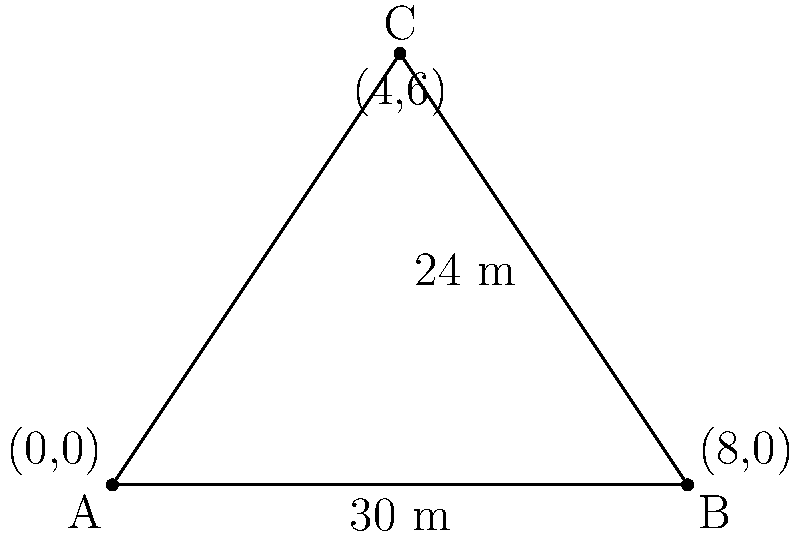A traditional Telugu temple gopuram has a triangular cross-section as shown in the diagram. If the base of the gopuram is 30 meters wide and its height is 24 meters, what is the angle of inclination (in degrees) of the gopuram's side with respect to the ground? Let's approach this step-by-step:

1) The diagram shows a right-angled triangle. We need to find the angle between the base and the hypotenuse.

2) We know:
   - The base (width) of the gopuram = 30 meters
   - The height of the gopuram = 24 meters

3) In this right-angled triangle:
   - The base is half of the total width: $\frac{30}{2} = 15$ meters
   - The height is 24 meters

4) To find the angle, we can use the trigonometric function tangent:

   $$\tan(\theta) = \frac{\text{opposite}}{\text{adjacent}} = \frac{\text{height}}{\text{half base}}$$

5) Plugging in our values:

   $$\tan(\theta) = \frac{24}{15}$$

6) To get the angle, we need to use the inverse tangent (arctan or $\tan^{-1}$):

   $$\theta = \tan^{-1}\left(\frac{24}{15}\right)$$

7) Using a calculator or computer:

   $$\theta \approx 57.99^\circ$$

8) Rounding to the nearest degree:

   $$\theta \approx 58^\circ$$

Thus, the angle of inclination of the gopuram's side with respect to the ground is approximately 58°.
Answer: 58° 